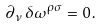<formula> <loc_0><loc_0><loc_500><loc_500>\partial _ { \nu } \, \delta \omega ^ { \rho \sigma } = 0 \, .</formula> 